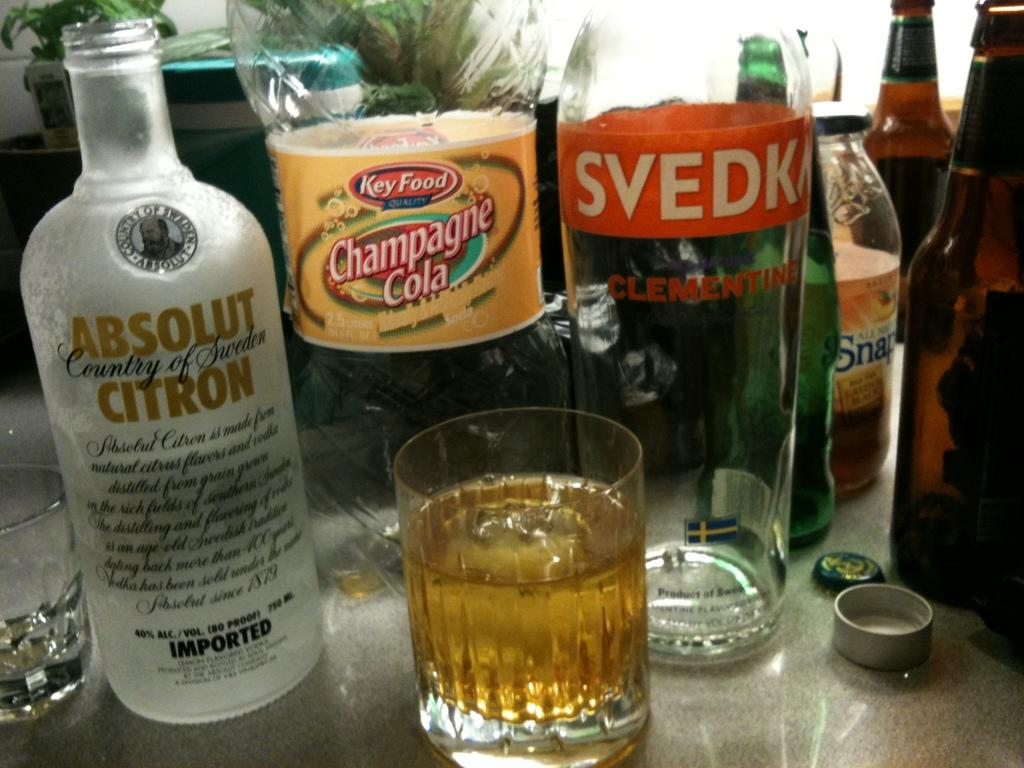<image>
Provide a brief description of the given image. A bottle of Absolut Citron and a glass next to it. 